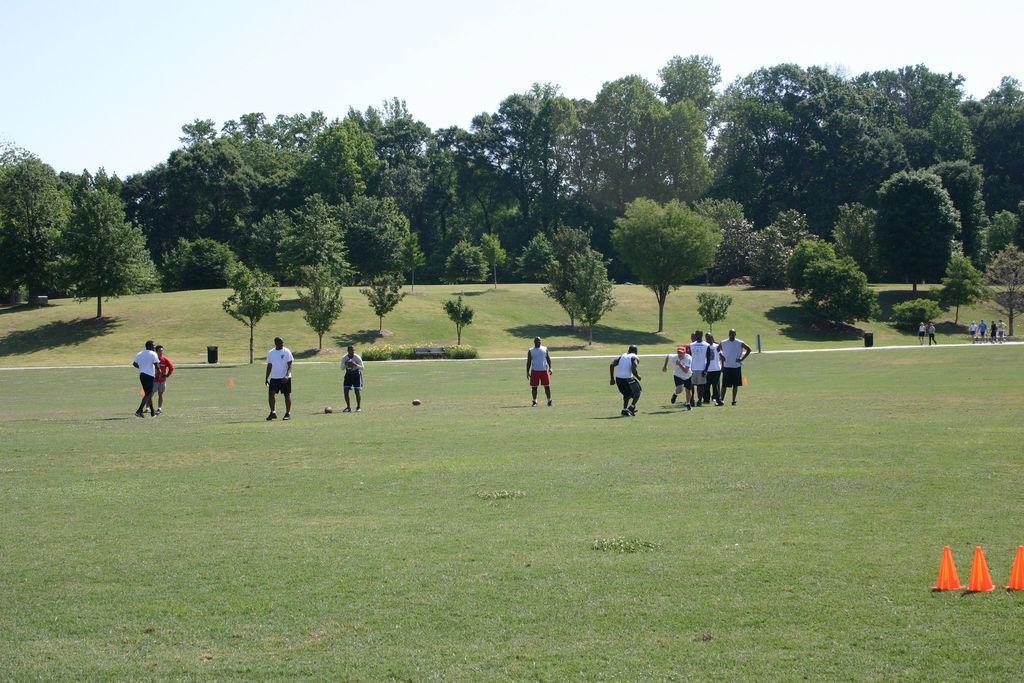Can you describe this image briefly? In the background we can see the sky, trees, plants. In this picture we can see the people. Few are walking and few are playing. We can see the balls and traffic cones on the green grass. Far we can see the black objects. 